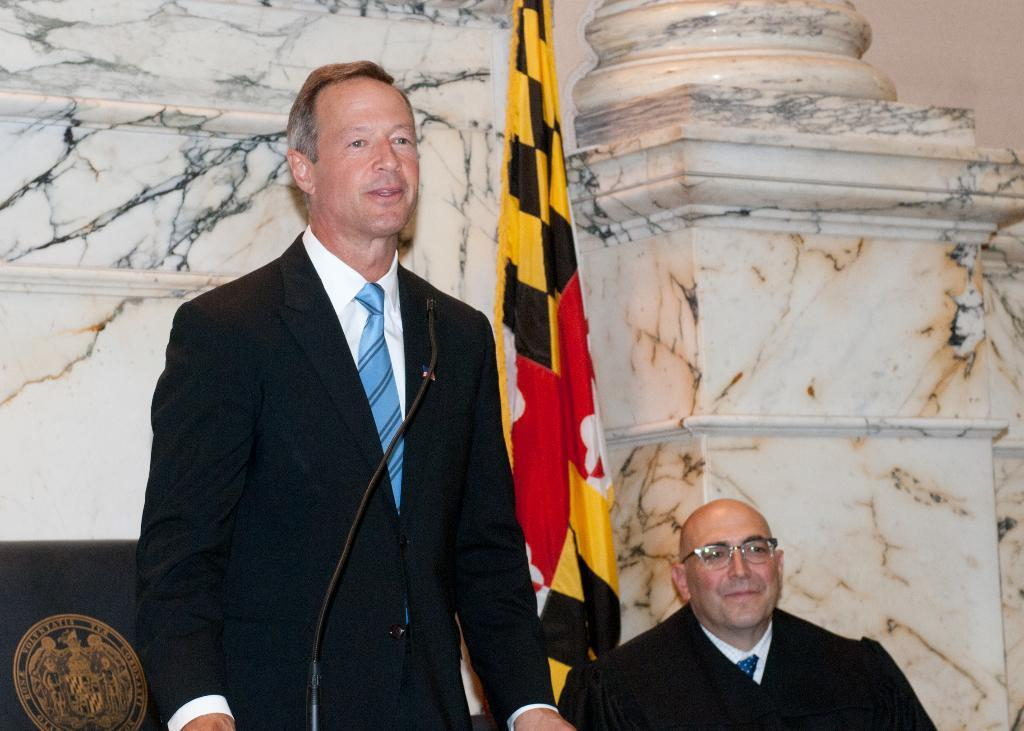What is the man standing in the image doing? The man standing in the image is likely using the microphone (mic) in front of him. Who else is present in the image? There is a man sitting next to the standing man. What can be seen in the background of the image? There is a wall in the background of the image. Are there any other notable elements in the image? Yes, there is a flag visible in the image. How many chairs are visible in the image? There are no chairs visible in the image. What type of belief is represented by the flag in the image? The image does not provide enough information to determine the belief represented by the flag. 